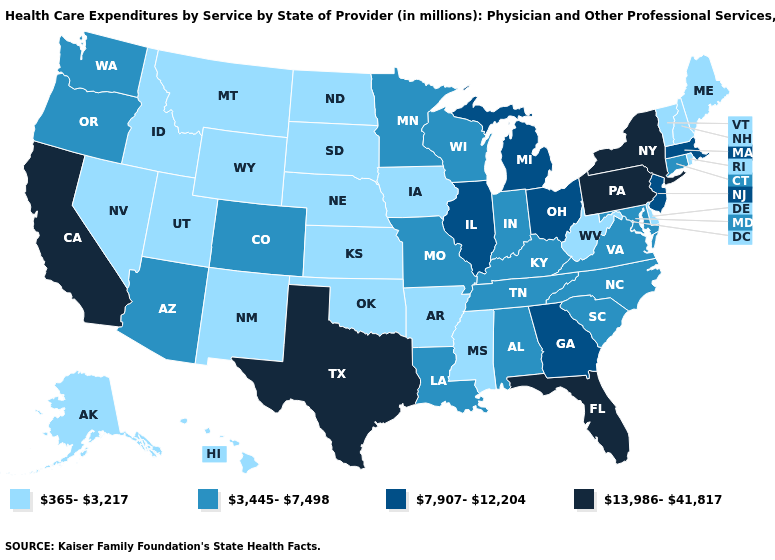How many symbols are there in the legend?
Give a very brief answer. 4. What is the value of Utah?
Short answer required. 365-3,217. Name the states that have a value in the range 3,445-7,498?
Write a very short answer. Alabama, Arizona, Colorado, Connecticut, Indiana, Kentucky, Louisiana, Maryland, Minnesota, Missouri, North Carolina, Oregon, South Carolina, Tennessee, Virginia, Washington, Wisconsin. What is the value of Louisiana?
Keep it brief. 3,445-7,498. Which states hav the highest value in the South?
Concise answer only. Florida, Texas. How many symbols are there in the legend?
Short answer required. 4. What is the lowest value in states that border Iowa?
Quick response, please. 365-3,217. Name the states that have a value in the range 7,907-12,204?
Short answer required. Georgia, Illinois, Massachusetts, Michigan, New Jersey, Ohio. Does Pennsylvania have the highest value in the Northeast?
Quick response, please. Yes. Among the states that border North Dakota , does South Dakota have the highest value?
Concise answer only. No. Among the states that border Delaware , which have the highest value?
Write a very short answer. Pennsylvania. What is the lowest value in the Northeast?
Answer briefly. 365-3,217. What is the value of Arkansas?
Answer briefly. 365-3,217. What is the value of Vermont?
Short answer required. 365-3,217. What is the value of South Dakota?
Short answer required. 365-3,217. 